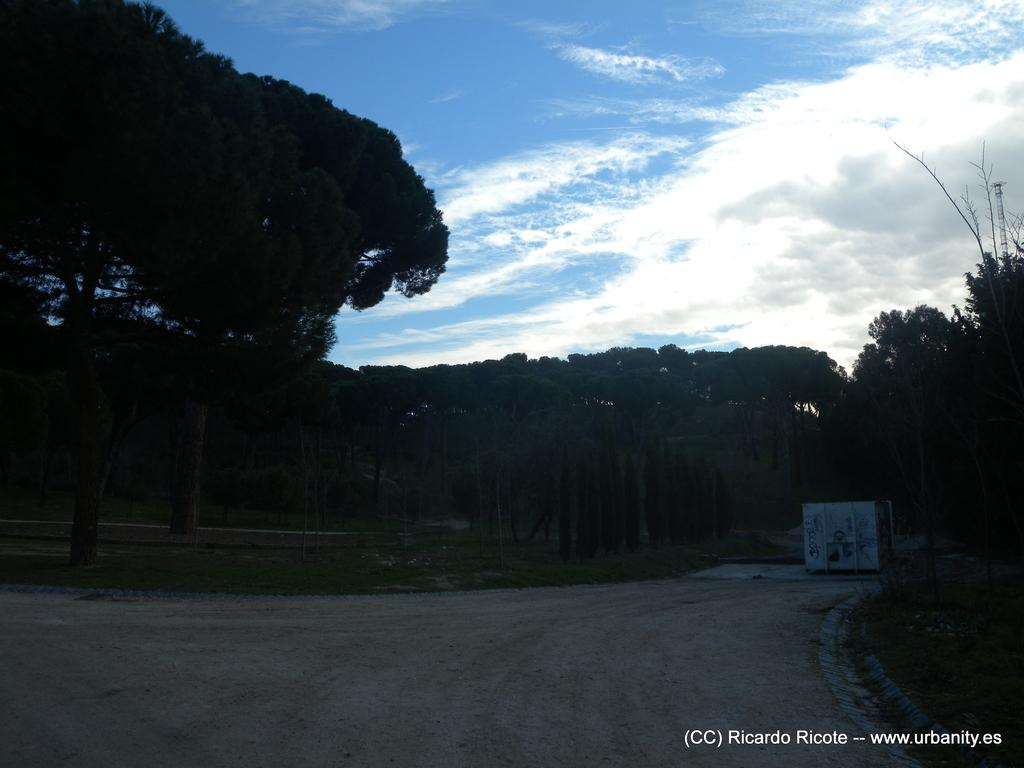What is the main subject of the image? The main subject of the image is not specified in the provided facts. Are there any objects or elements present in the image? The provided facts do not mention any specific objects or elements in the image. Can you describe the background or setting of the image? The provided facts do not give any information about the background or setting of the image. Is there any action or event taking place in the image? The provided facts do not mention any action or event happening in the image. Reasoning: Since there are no specific facts provided about the image, we cannot create a conversation based on the given information. Instead, we have to acknowledge the lack of details and avoid making any assumptions about the image. Absurd Question/Answer: What type of key is used to unlock the spoon in the image? There is no key or spoon present in the image, as the provided facts do not mention any such objects. 